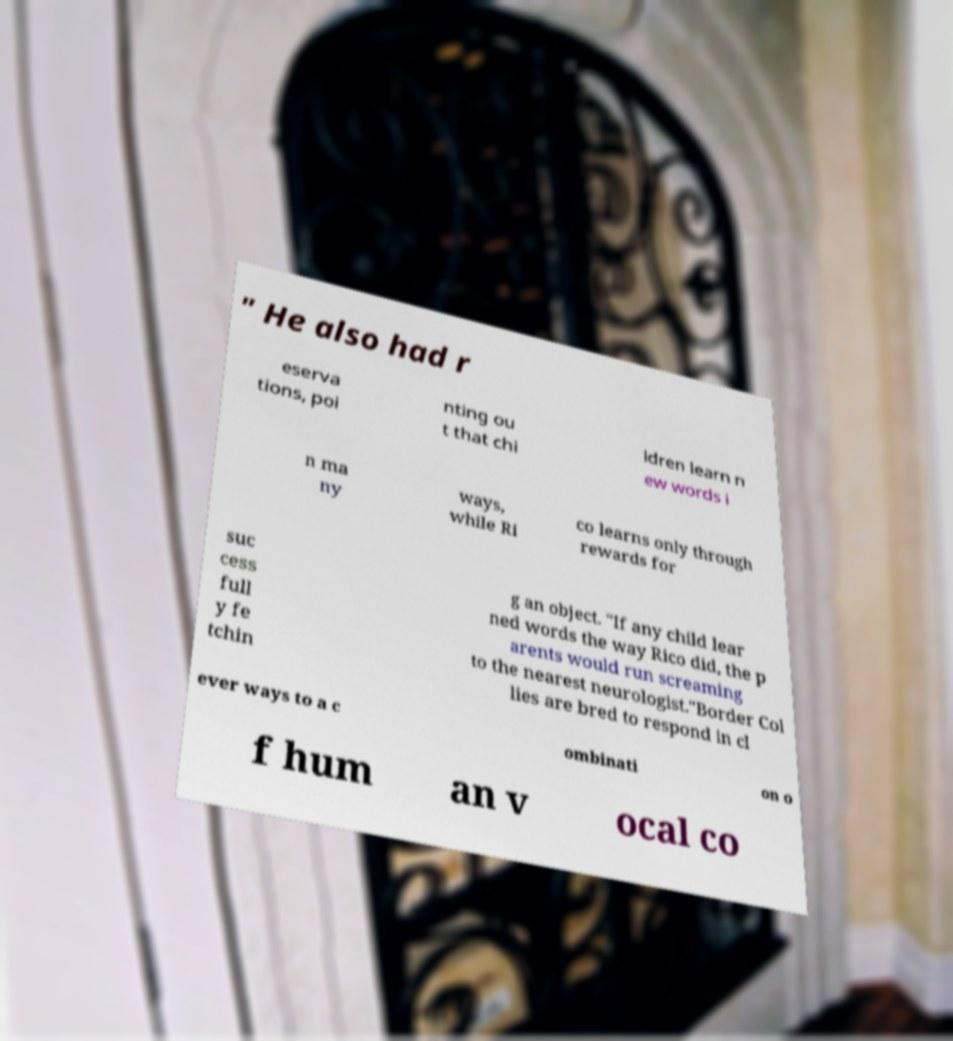For documentation purposes, I need the text within this image transcribed. Could you provide that? " He also had r eserva tions, poi nting ou t that chi ldren learn n ew words i n ma ny ways, while Ri co learns only through rewards for suc cess full y fe tchin g an object. "If any child lear ned words the way Rico did, the p arents would run screaming to the nearest neurologist."Border Col lies are bred to respond in cl ever ways to a c ombinati on o f hum an v ocal co 